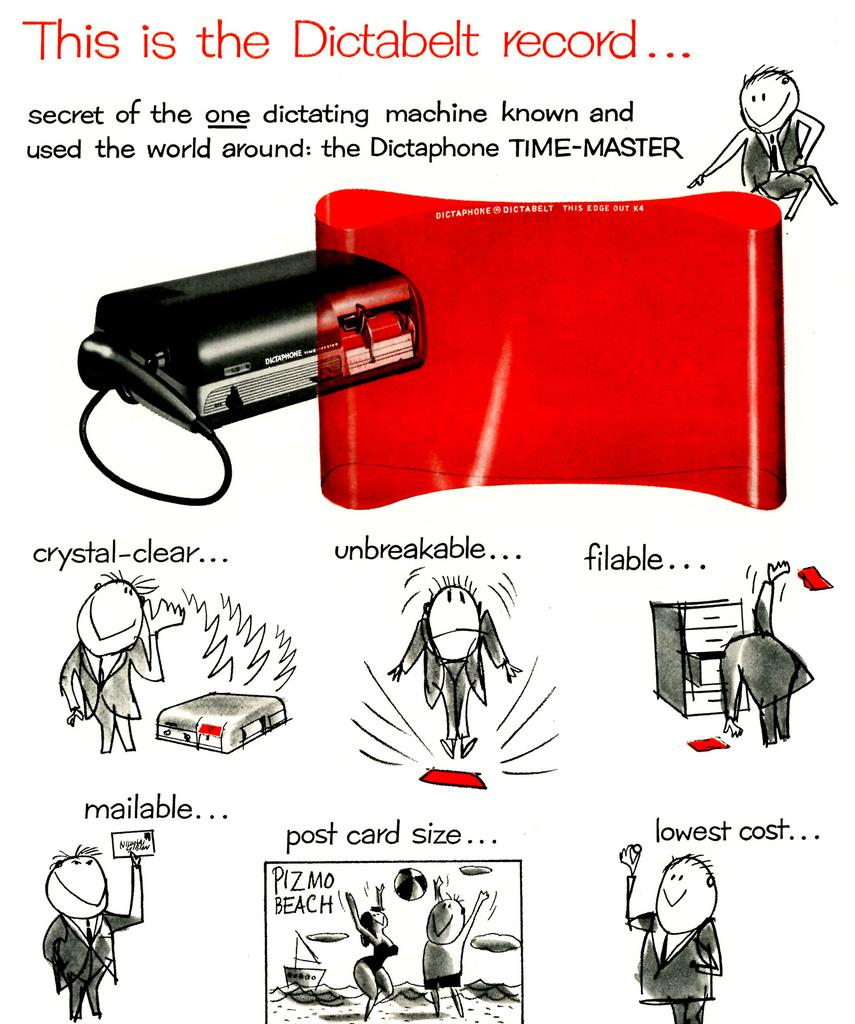<image>
Relay a brief, clear account of the picture shown. An old ad for the Dictabelt dictating machine proclaims it as the Time Master. 